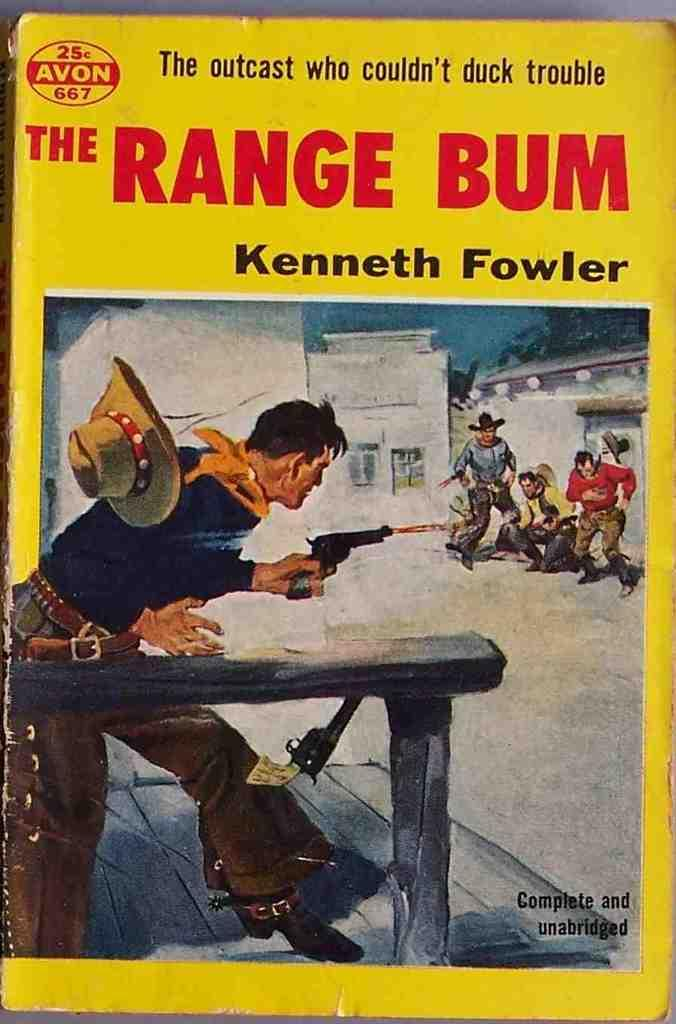What type of page is shown in the image? The image is a cover page of a book. What can be seen on the cover page besides text? There are images on the cover page. What information is provided on the cover page? There is text on the cover page. How does the friction between the pages affect the net weight of the book in the image? There is no mention of friction, net weight, or pages in the image, as it only shows a cover page with images and text. 